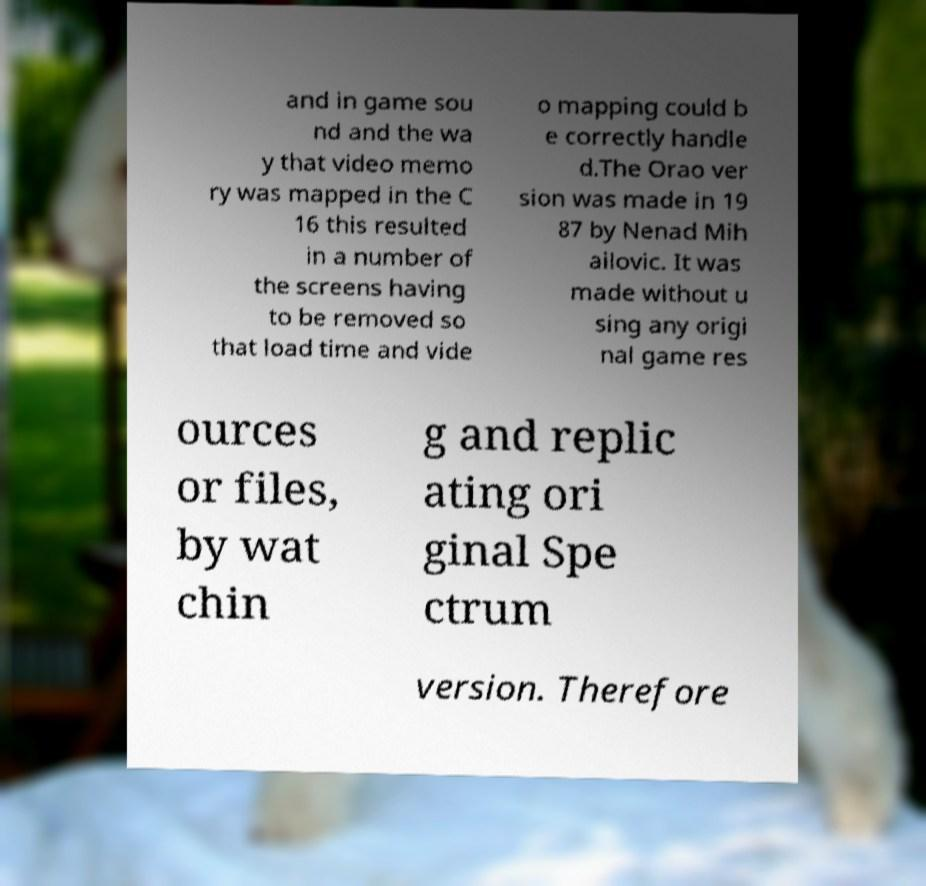Could you assist in decoding the text presented in this image and type it out clearly? and in game sou nd and the wa y that video memo ry was mapped in the C 16 this resulted in a number of the screens having to be removed so that load time and vide o mapping could b e correctly handle d.The Orao ver sion was made in 19 87 by Nenad Mih ailovic. It was made without u sing any origi nal game res ources or files, by wat chin g and replic ating ori ginal Spe ctrum version. Therefore 